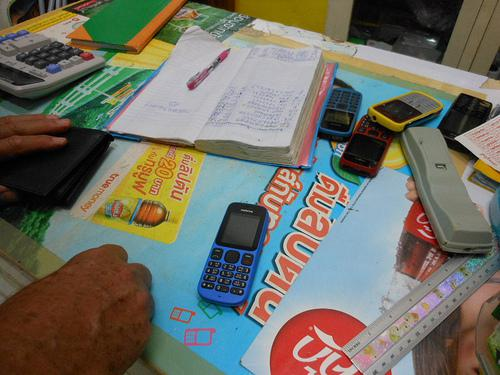Question: who hand's in the picture?
Choices:
A. A man's.
B. A woman's.
C. A girl's.
D. A boy's.
Answer with the letter. Answer: A Question: what is used for writing on the desk?
Choices:
A. A lead pencil.
B. A marker.
C. A pen.
D. A colored pencil.
Answer with the letter. Answer: C 